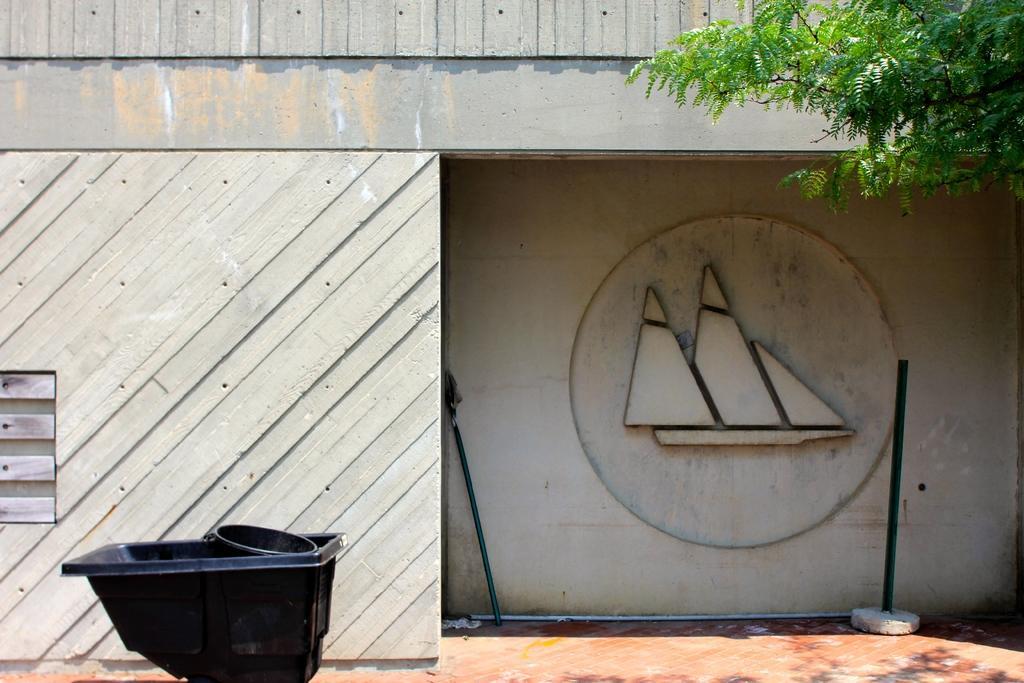In one or two sentences, can you explain what this image depicts? In this picture I can observe a tree in the top right side. In the background there is a wall. On the right side I can observe a pole. On the left side there is a black color pulling cart. 